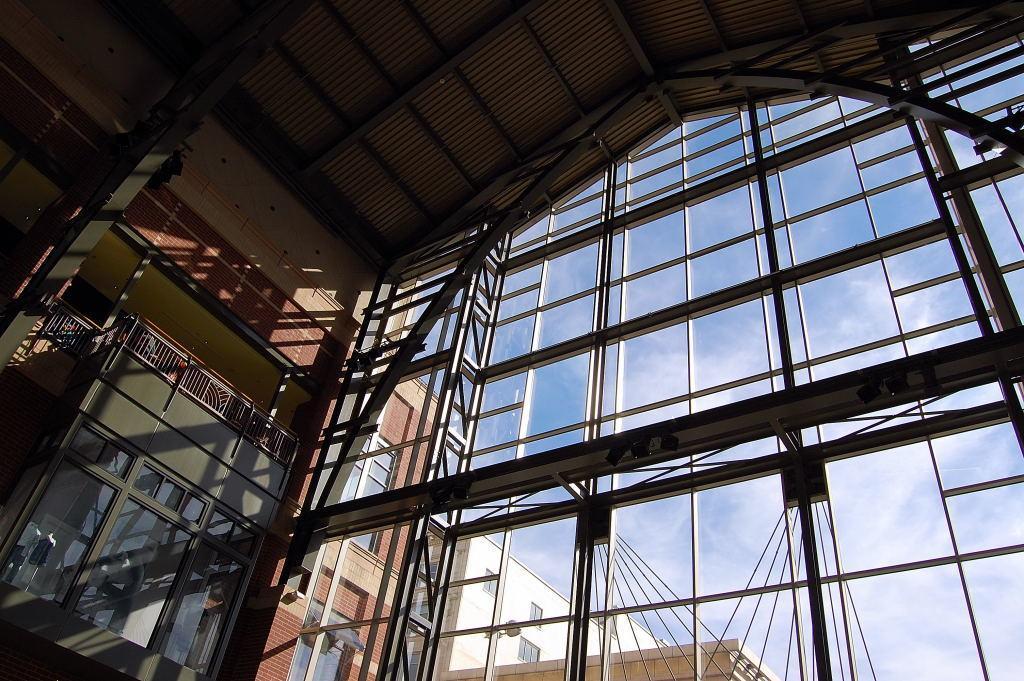Could you give a brief overview of what you see in this image? This picture might be taken inside the building. In this image, on the right side, we can see a metal grill. On the left side, we can see a building, glass window. Outside the glass window, we can see a building, brick wall, glass window. At the top, we can see a sky. 